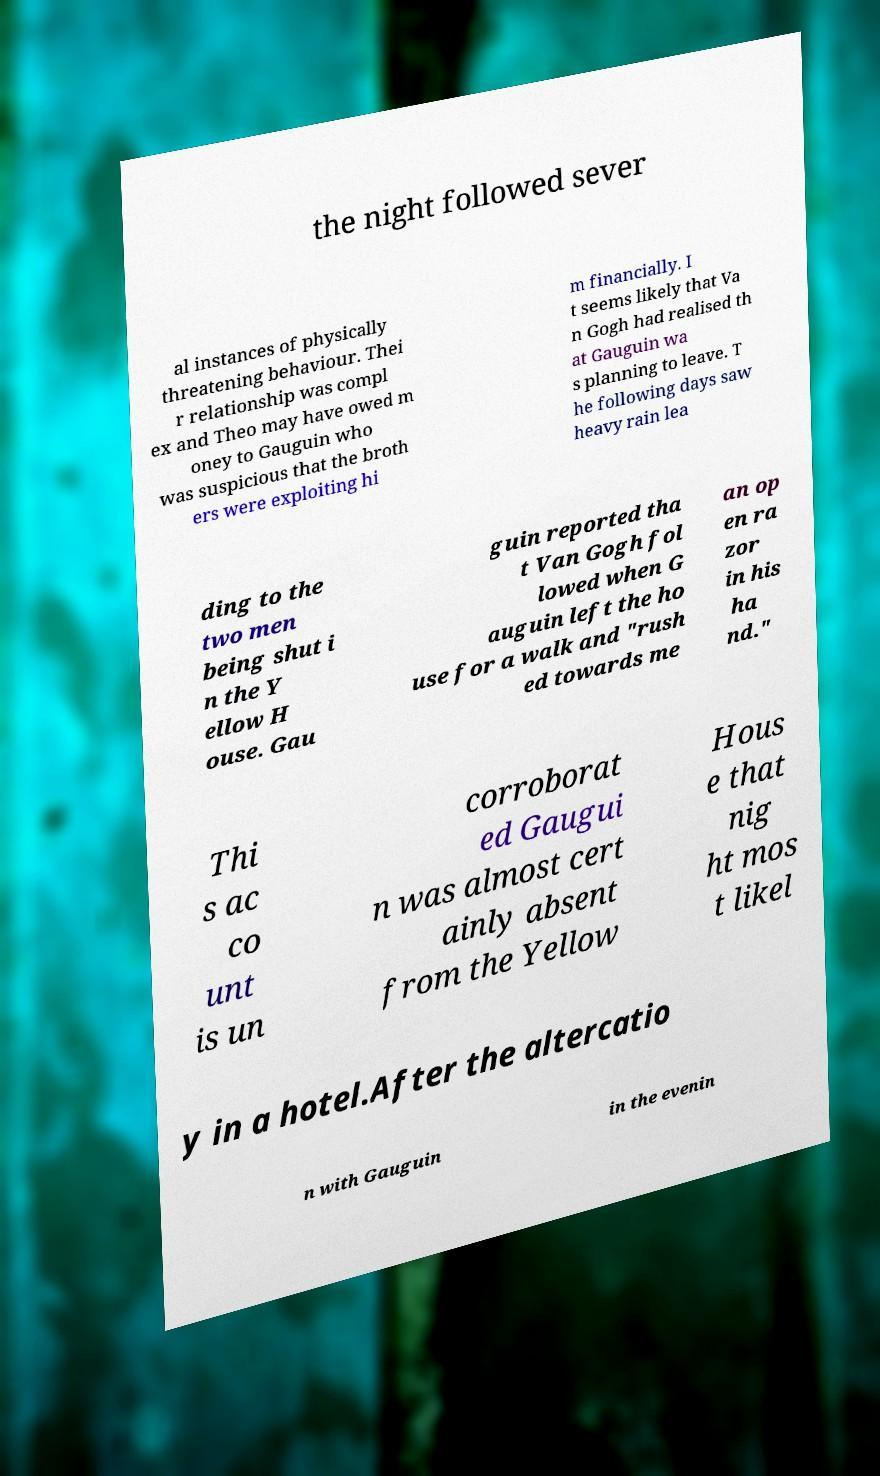For documentation purposes, I need the text within this image transcribed. Could you provide that? the night followed sever al instances of physically threatening behaviour. Thei r relationship was compl ex and Theo may have owed m oney to Gauguin who was suspicious that the broth ers were exploiting hi m financially. I t seems likely that Va n Gogh had realised th at Gauguin wa s planning to leave. T he following days saw heavy rain lea ding to the two men being shut i n the Y ellow H ouse. Gau guin reported tha t Van Gogh fol lowed when G auguin left the ho use for a walk and "rush ed towards me an op en ra zor in his ha nd." Thi s ac co unt is un corroborat ed Gaugui n was almost cert ainly absent from the Yellow Hous e that nig ht mos t likel y in a hotel.After the altercatio n with Gauguin in the evenin 